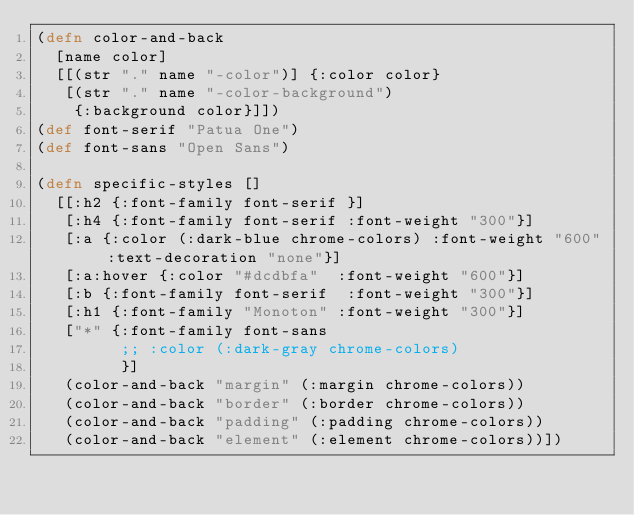<code> <loc_0><loc_0><loc_500><loc_500><_Clojure_>(defn color-and-back
  [name color]
  [[(str "." name "-color")] {:color color}
   [(str "." name "-color-background")
    {:background color}]])
(def font-serif "Patua One")
(def font-sans "Open Sans")

(defn specific-styles []
  [[:h2 {:font-family font-serif }]
   [:h4 {:font-family font-serif :font-weight "300"}]
   [:a {:color (:dark-blue chrome-colors) :font-weight "600" :text-decoration "none"}]
   [:a:hover {:color "#dcdbfa"  :font-weight "600"}]
   [:b {:font-family font-serif  :font-weight "300"}]
   [:h1 {:font-family "Monoton" :font-weight "300"}]
   ["*" {:font-family font-sans
         ;; :color (:dark-gray chrome-colors)
         }]
   (color-and-back "margin" (:margin chrome-colors))
   (color-and-back "border" (:border chrome-colors))
   (color-and-back "padding" (:padding chrome-colors))
   (color-and-back "element" (:element chrome-colors))])


</code> 